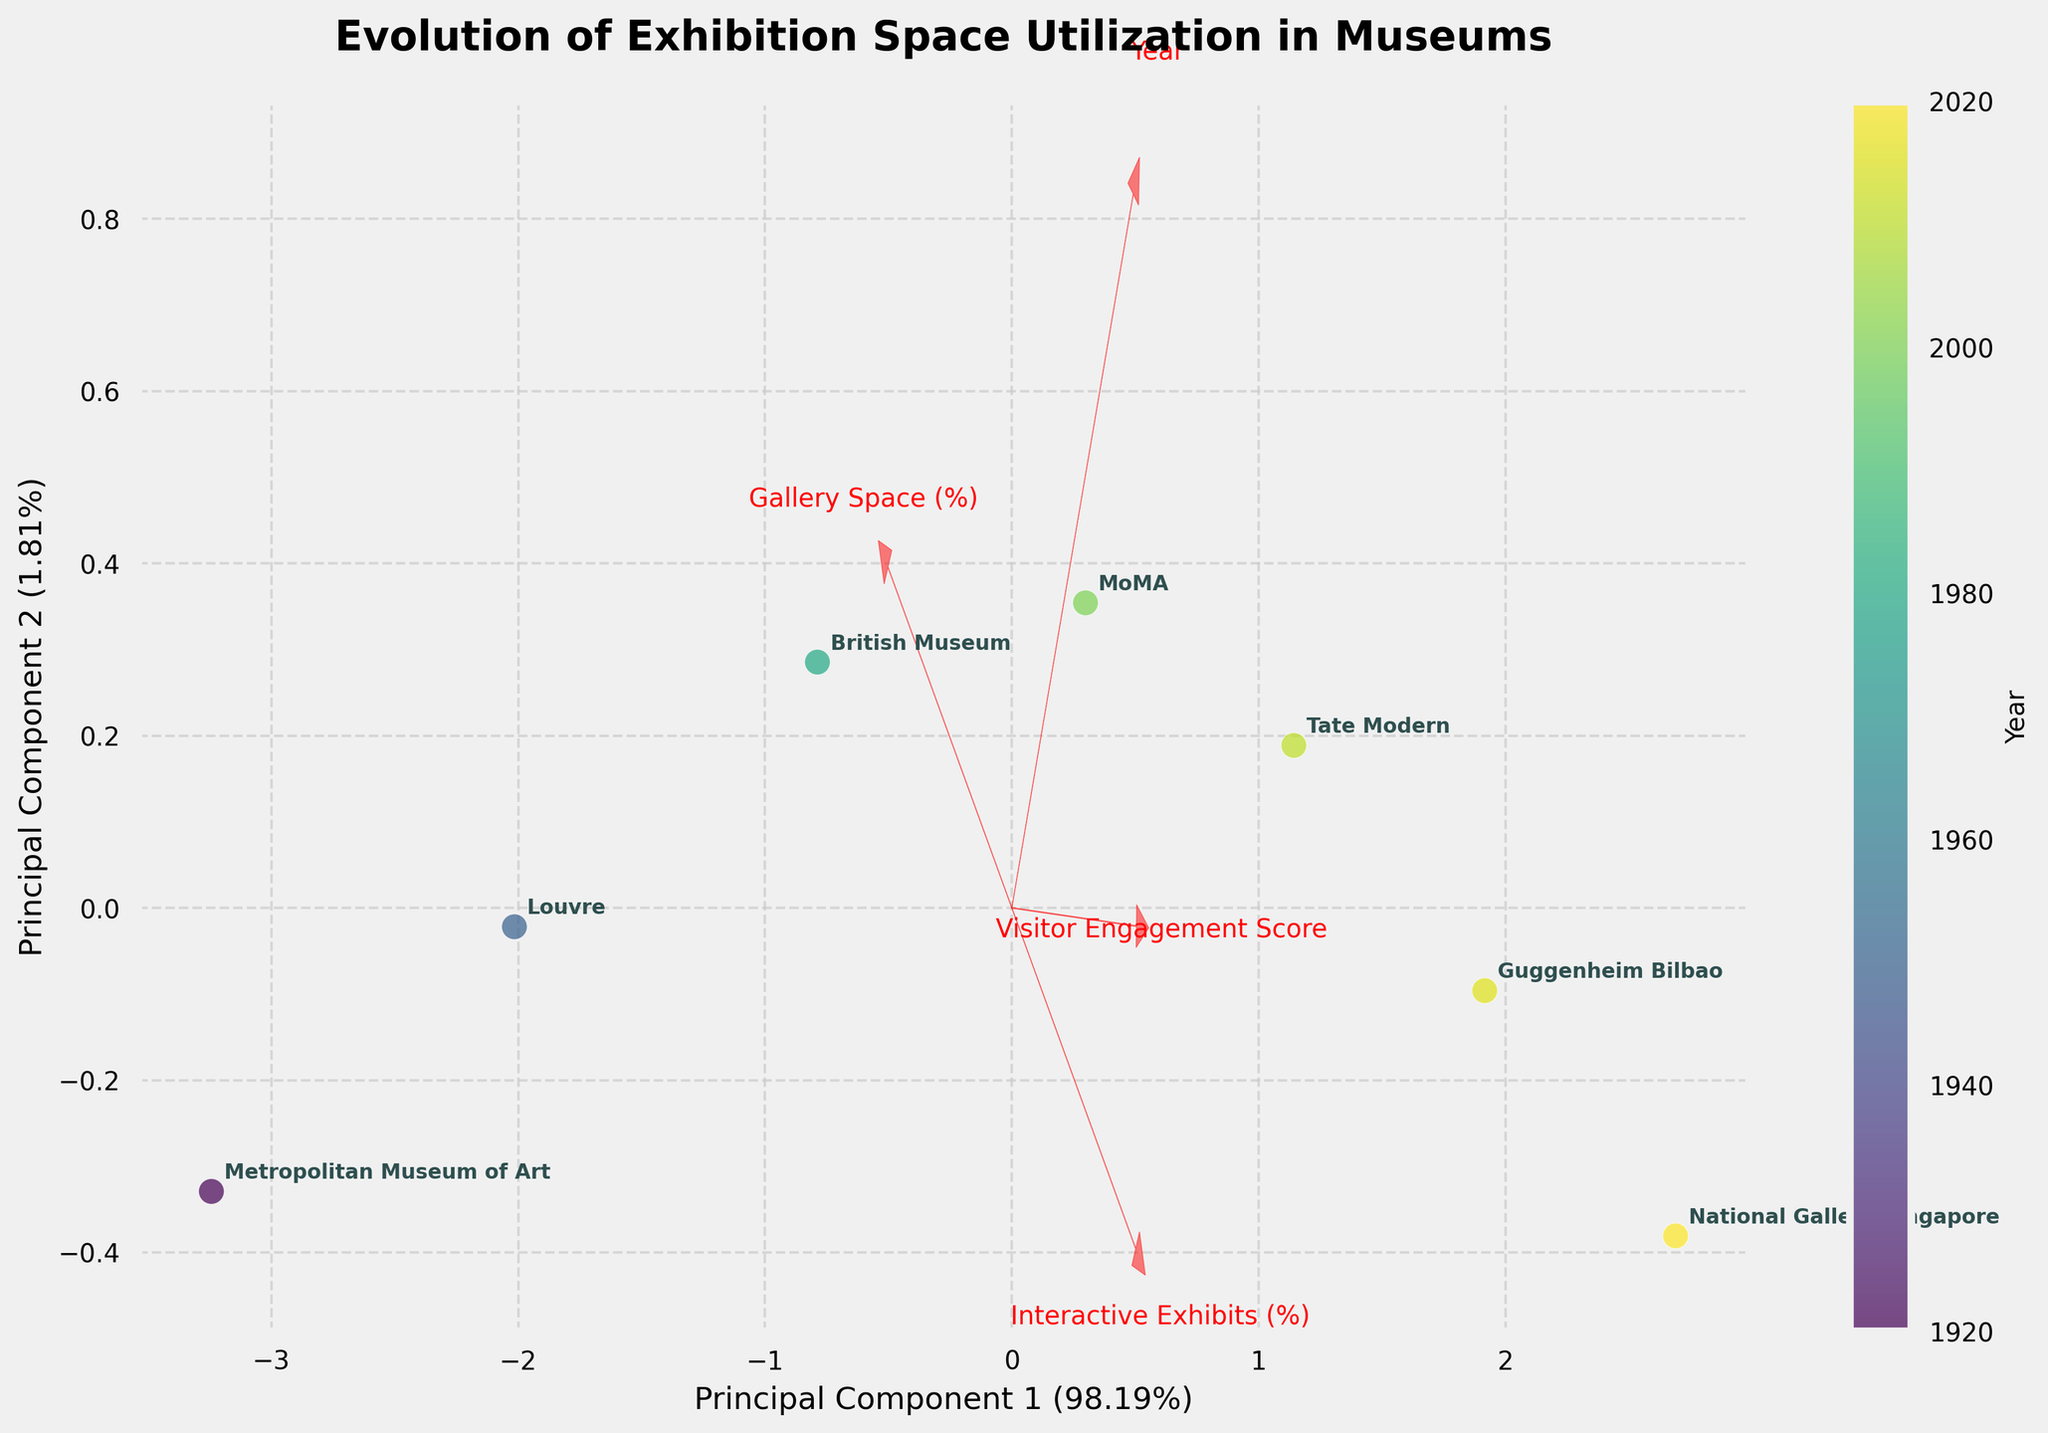How many data points are visible in the biplot? By counting the visible points labeled with the museum names in the biplot, we note seven different data points.
Answer: 7 What is the title of the biplot? The title is usually displayed at the top of the plot, and it reads "Evolution of Exhibition Space Utilization in Museums."
Answer: Evolution of Exhibition Space Utilization in Museums Which museum has the highest Visitor Engagement Score? The arrow representing 'Visitor Engagement Score' in the biplot is pointing towards a certain direction. The National Gallery Singapore, closest to the direction of this arrow, has the highest score.
Answer: National Gallery Singapore Which year has the darkest color on the color gradient used for points? On the gradient color scale, darker colors represent more recent years. The darkest color corresponds to the year 2020.
Answer: 2020 What is the relationship between the "Year" and "Gallery Space (%)" based on the biplot vectors? We observe the directions of the vectors for "Year" and "Gallery Space (%)". They point in almost opposite directions, indicating an inverse relationship.
Answer: Inverse relationship Which principal component explains the most variance, and by how much? The x-axis is labeled "Principal Component 1" and "Principal Component 2" with variance percentages. "Principal Component 1" explains 52% of the variance, which is more than "Principal Component 2."
Answer: Principal Component 1 by 52% Compare the positioning of the Metropolitan Museum of Art and the National Gallery Singapore in terms of "Gallery Space (%)" and "Interactive Exhibits (%)". The Metropolitan Museum of Art is positioned near the "Gallery Space (%)" arrow, indicating it has a higher percentage of gallery space. Conversely, the National Gallery Singapore is near the "Interactive Exhibits (%)" arrow, indicating it has a higher percentage of interactive exhibits.
Answer: Higher for MMArt in gallery space, higher for NG Singapore in interactive exhibits What does the color of the museums' points indicate? The color of the points is associated with the "Year" variable. The color gradient bar on the side ranges from lighter colors (earlier years) to darker colors (recent years).
Answer: Year What pattern do you observe in the evolution of interactive exhibits from 1920 to 2020? By observing the positioning along the "Interactive Exhibits (%)" arrow, there is a clear upward trend over the years, going from the Metropolitan Museum of Art (with the lowest percentage) to the National Gallery Singapore (with the highest percentage).
Answer: Increasing trend Is there a significant correlation between the "Year" and "Visitor Engagement Score"? Explain your reasoning. The vectors for "Year" and "Visitor Engagement Score" point in a very similar direction in the biplot, indicating a strong positive correlation. Increasing years correspond to higher visitor engagement scores.
Answer: Strong positive correlation 